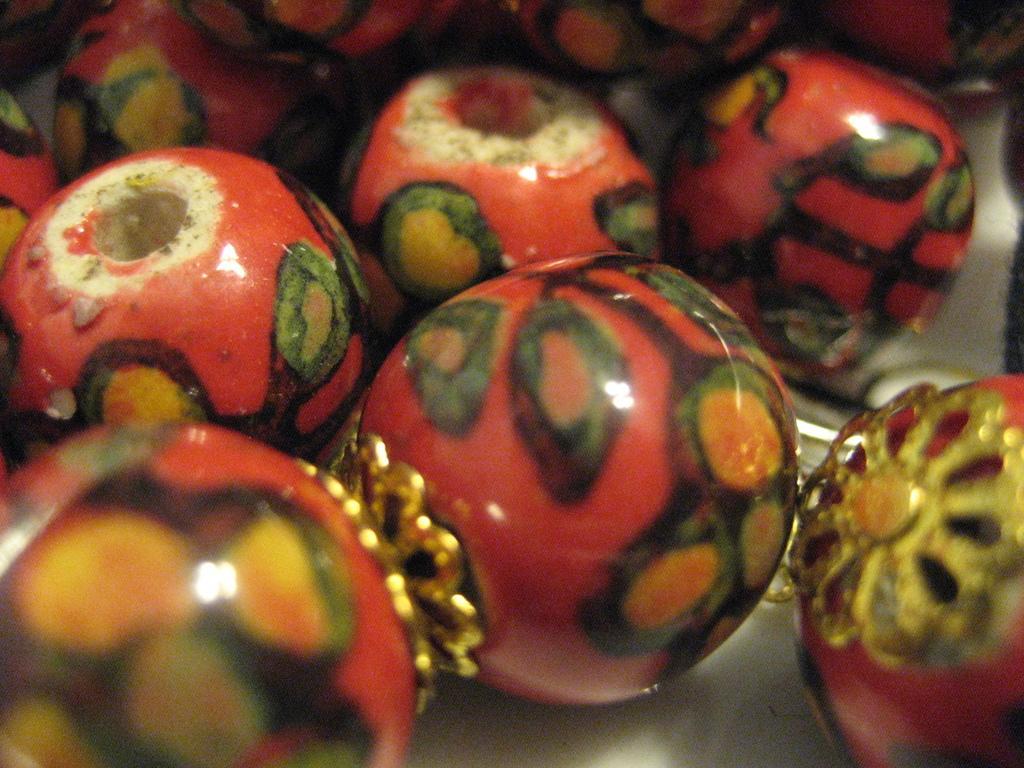In one or two sentences, can you explain what this image depicts? In this picture I can see beads. 